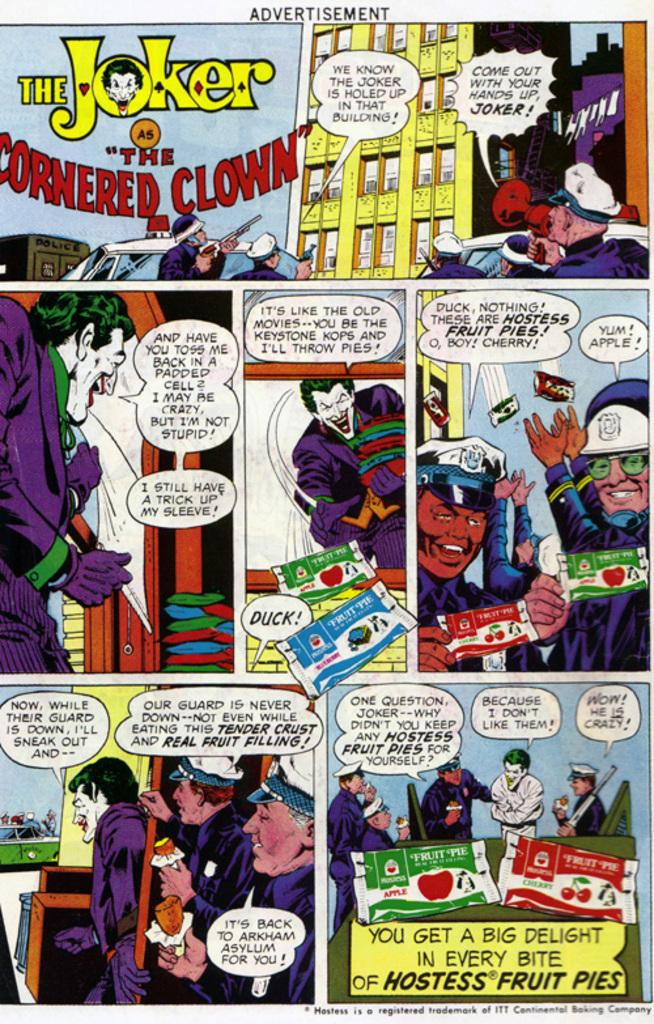<image>
Offer a succinct explanation of the picture presented. a comic that is for the Batmal villain called The Joker 